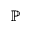Convert formula to latex. <formula><loc_0><loc_0><loc_500><loc_500>\mathbb { P }</formula> 